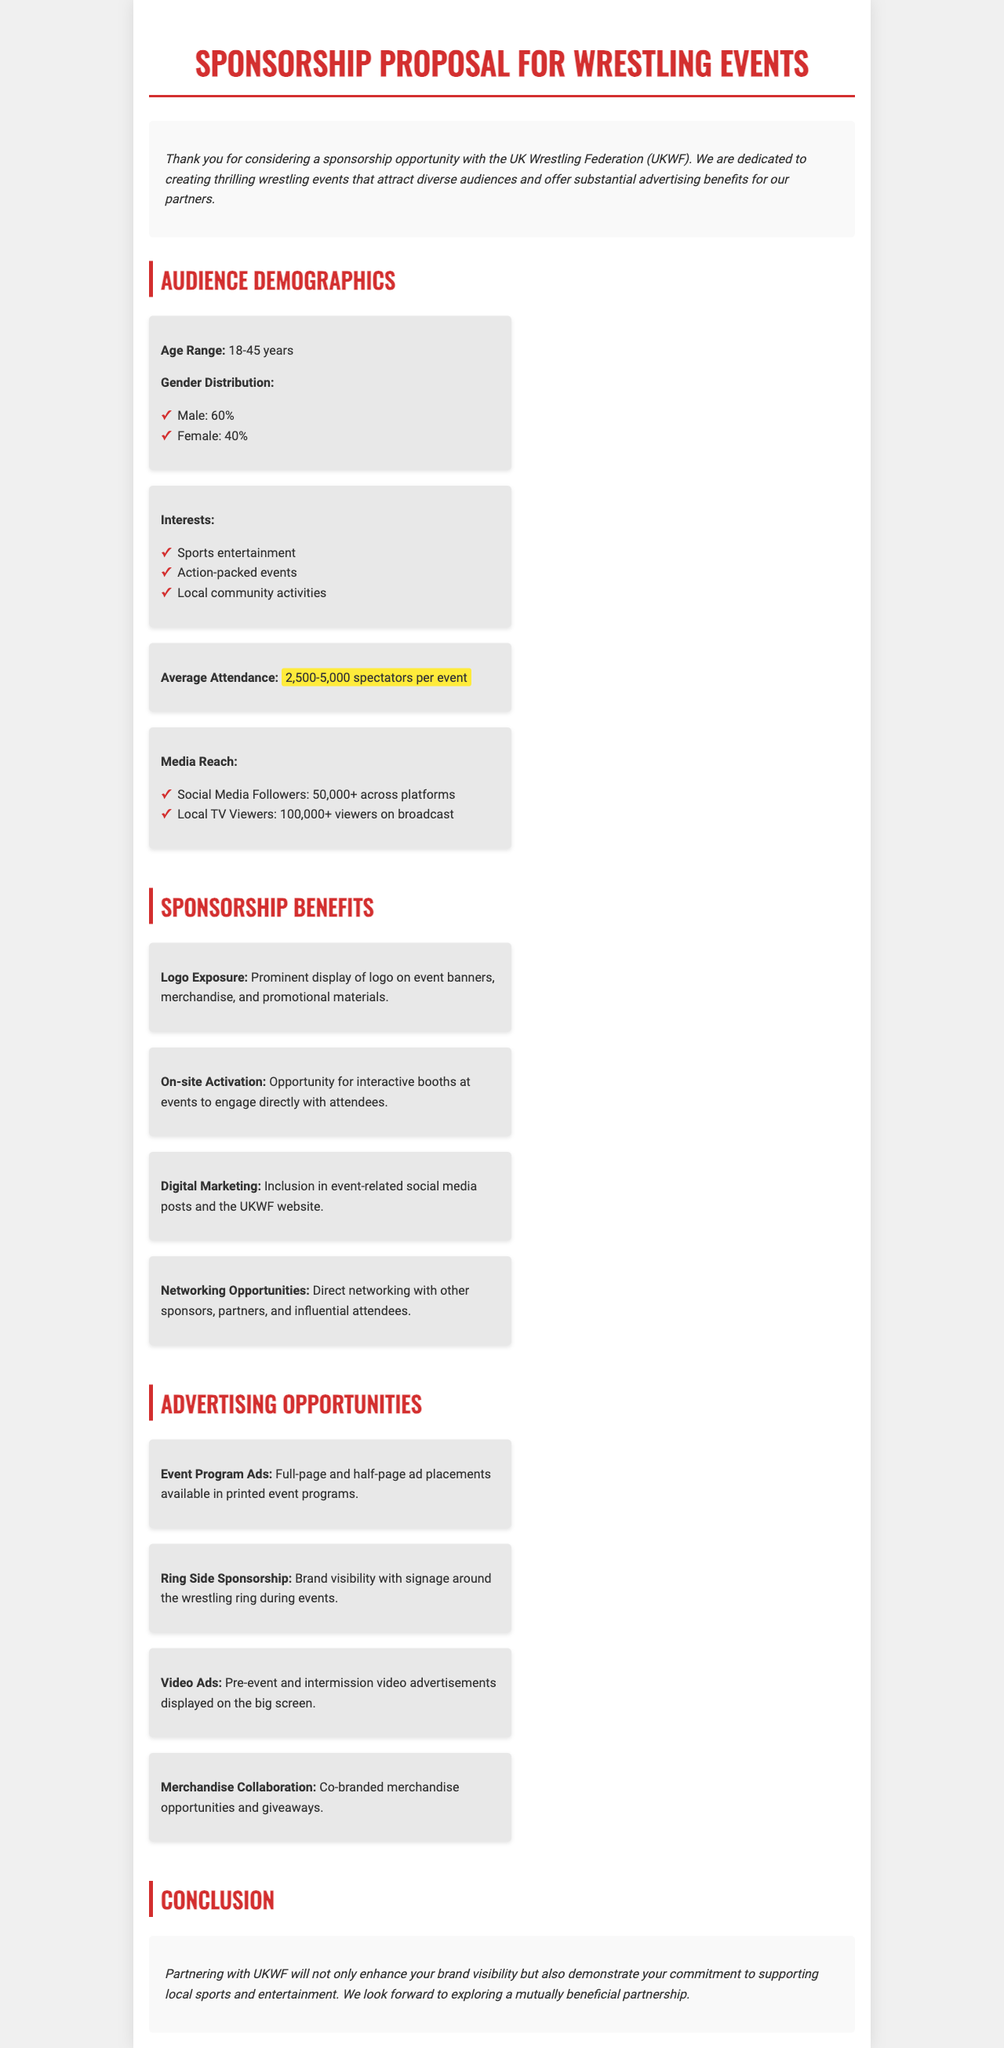What is the average attendance at events? The average attendance is mentioned as the range of spectators per event, which is 2,500-5,000.
Answer: 2,500-5,000 spectators What is the male gender distribution percentage? The document states the gender distribution, specifying that male attendees comprise 60% of the audience.
Answer: 60% What are two listed interests of the audience? The interests of the audience are detailed in a list, including sports entertainment and action-packed events.
Answer: Sports entertainment, action-packed events What type of sponsorship opportunity is available for signage? The document lists sponsorship opportunities that include brand visibility with signage around the wrestling ring during events.
Answer: Ring Side Sponsorship How many social media followers does UKWF have? The document mentions the number of social media followers that UKWF has across platforms, which is 50,000+.
Answer: 50,000+ What is the gender distribution percentage for females? The document provides a percentage for female attendees, specifying it as 40%.
Answer: 40% Which advertising opportunity includes the display of video ads? The document specifies that video advertisements are displayed on the big screen during events, particularly during pre-event and intermission.
Answer: Video Ads What is one benefit of sponsoring UKWF? The benefits of sponsorship are listed, one of which includes prominent display of logo on event banners, merchandise, and promotional materials.
Answer: Logo Exposure 